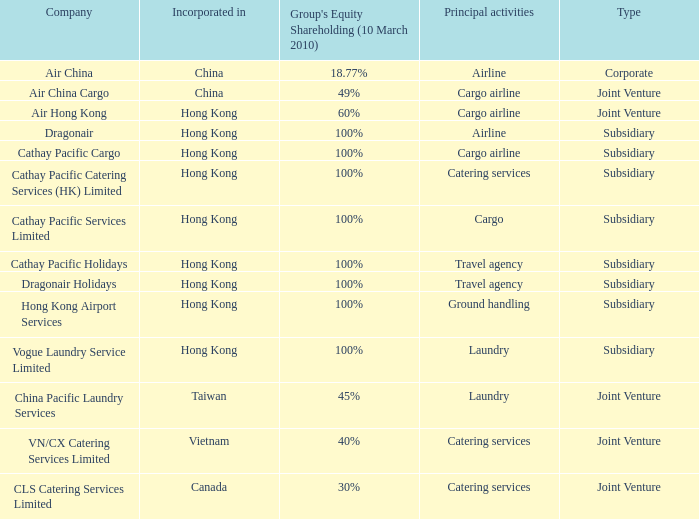What is the Group's equity share percentage for Company VN/CX catering services limited? 40%. 